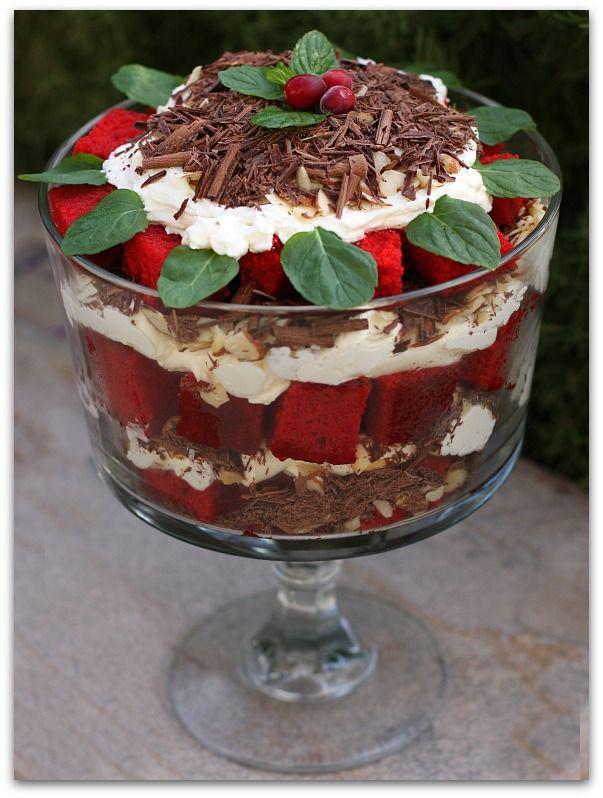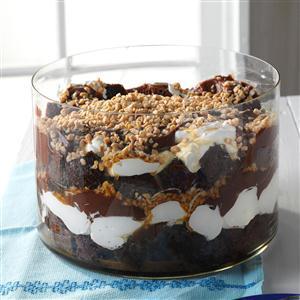The first image is the image on the left, the second image is the image on the right. For the images displayed, is the sentence "Exactly two large trifle desserts in clear footed bowls are shown, one made with chocolate layers and one made with strawberries." factually correct? Answer yes or no. No. The first image is the image on the left, the second image is the image on the right. Given the left and right images, does the statement "An image shows a layered dessert in a footed glass sitting directly on wood furniture." hold true? Answer yes or no. No. 